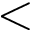<formula> <loc_0><loc_0><loc_500><loc_500><</formula> 